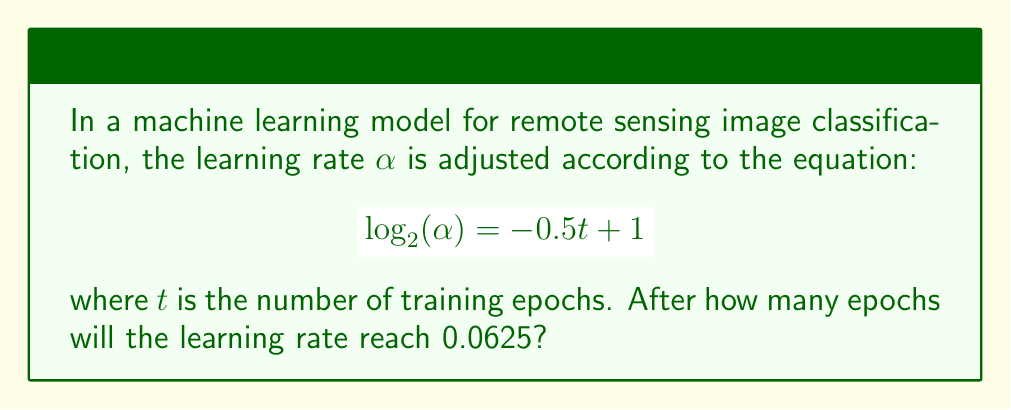Give your solution to this math problem. To solve this problem, we need to follow these steps:

1) We're looking for the value of $t$ when $\alpha = 0.0625$. Let's substitute this into the equation:

   $$\log_2(0.0625) = -0.5t + 1$$

2) First, let's simplify the left side of the equation. We know that $0.0625 = \frac{1}{16} = 2^{-4}$, so:

   $$-4 = -0.5t + 1$$

3) Now we can solve for $t$:
   
   $$-4 = -0.5t + 1$$
   $$-5 = -0.5t$$
   $$10 = t$$

4) To verify, we can substitute this value back into the original equation:

   $$\log_2(\alpha) = -0.5(10) + 1 = -5 + 1 = -4$$
   
   $$\alpha = 2^{-4} = 0.0625$$

This confirms our solution.
Answer: The learning rate will reach 0.0625 after 10 epochs. 